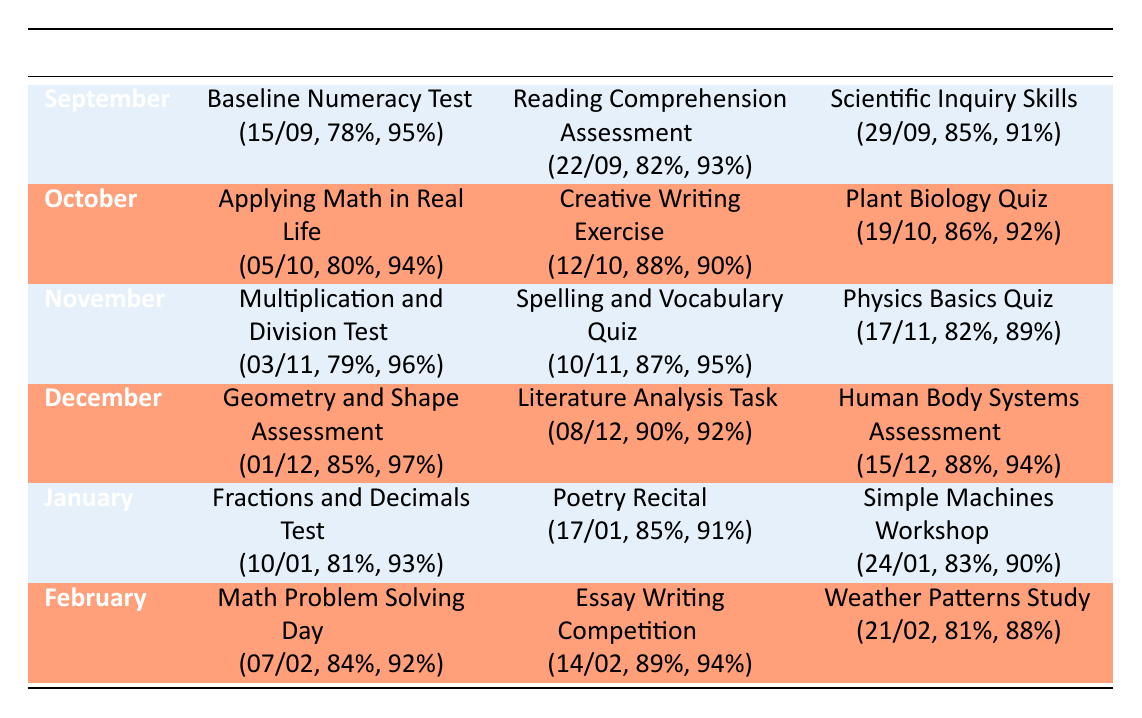What was the average score for the English assessments in December? In December, the average score for the English assessment (Literature Analysis Task) was 90.
Answer: 90 What is the participation percentage for the Science assessment in November? The participation percentage for the Science assessment (Physics Basics Quiz) in November was 89%.
Answer: 89% Which month had the highest average score in Mathematics? Looking at the table, December had the highest average score in Mathematics (85%).
Answer: December How many assessments were conducted in January? In January, there were three assessments conducted: one in Mathematics, one in English, and one in Science.
Answer: 3 Did more students participate in the Mathematics assessment in January compared to November? In January, the participation for the Mathematics assessment (Fractions and Decimals Test) was 93%, while in November it was 96%. Since 93% is less than 96%, the answer is no.
Answer: No What is the average score of the assessments in October? To find the average score for October, add the average scores: (80 + 88 + 86) = 254, then divide by 3, giving an average of 84.67.
Answer: 84.67 Is the average score for English assessments in February greater than the average score for Science assessments in the same month? The average score for the English assessment in February (89) is greater than the average score for the Science assessment (81), so the answer is yes.
Answer: Yes Which assessment had the lowest average score across all months? The lowest average score is for the Mathematics assessment in November (79).
Answer: 79 